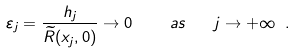<formula> <loc_0><loc_0><loc_500><loc_500>\varepsilon _ { j } = \frac { h _ { j } } { \widetilde { R } ( x _ { j } , 0 ) } \rightarrow 0 \ \quad a s \quad j \rightarrow + \infty \ .</formula> 